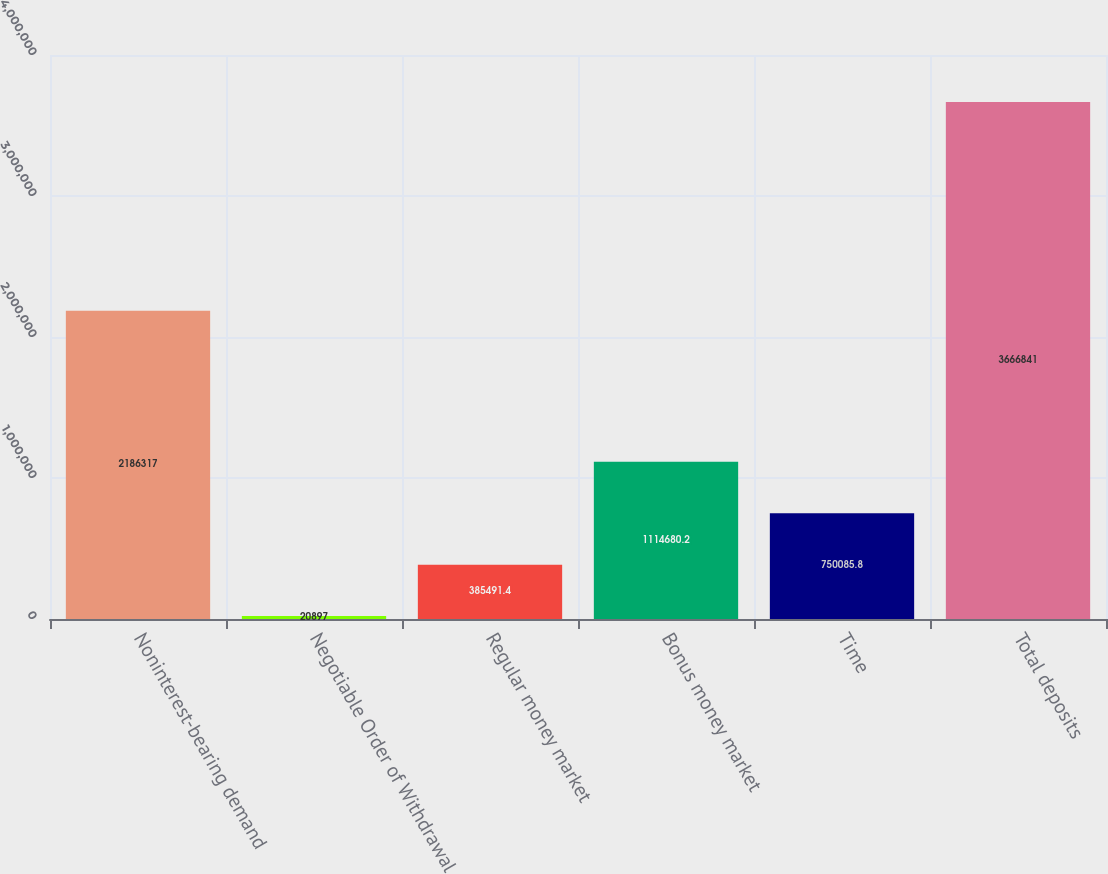Convert chart. <chart><loc_0><loc_0><loc_500><loc_500><bar_chart><fcel>Noninterest-bearing demand<fcel>Negotiable Order of Withdrawal<fcel>Regular money market<fcel>Bonus money market<fcel>Time<fcel>Total deposits<nl><fcel>2.18632e+06<fcel>20897<fcel>385491<fcel>1.11468e+06<fcel>750086<fcel>3.66684e+06<nl></chart> 